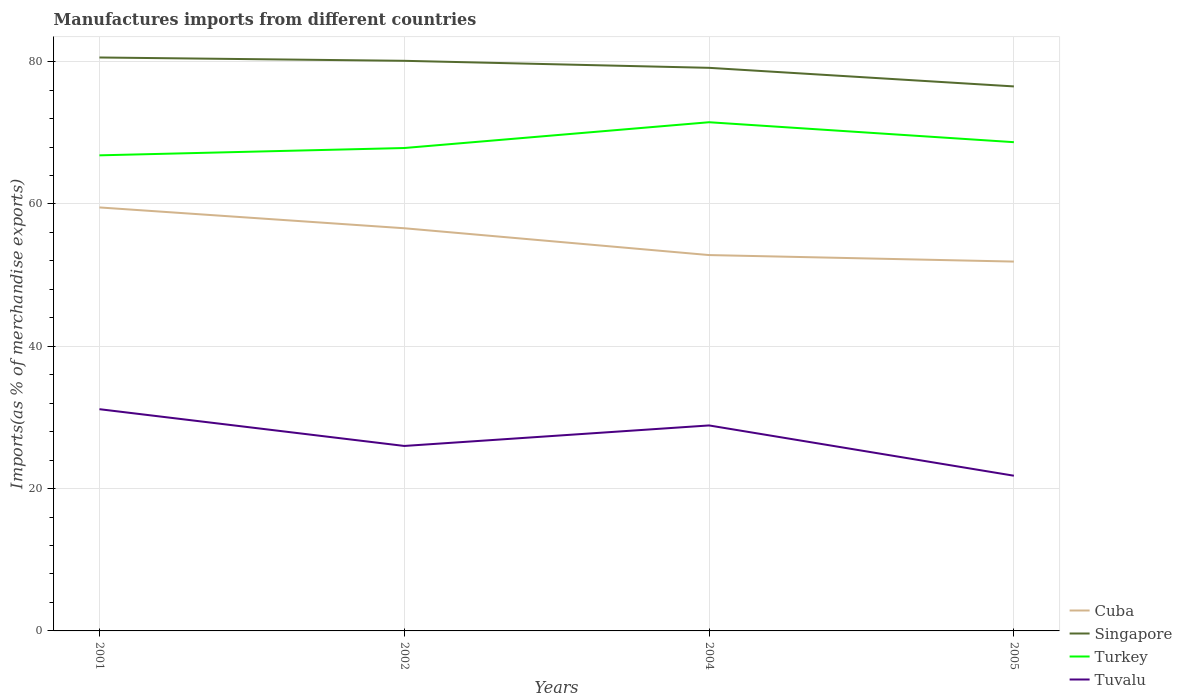How many different coloured lines are there?
Your answer should be compact. 4. Does the line corresponding to Turkey intersect with the line corresponding to Tuvalu?
Keep it short and to the point. No. Across all years, what is the maximum percentage of imports to different countries in Cuba?
Keep it short and to the point. 51.9. In which year was the percentage of imports to different countries in Cuba maximum?
Provide a succinct answer. 2005. What is the total percentage of imports to different countries in Tuvalu in the graph?
Provide a short and direct response. 4.18. What is the difference between the highest and the second highest percentage of imports to different countries in Tuvalu?
Keep it short and to the point. 9.35. What is the difference between two consecutive major ticks on the Y-axis?
Provide a short and direct response. 20. Are the values on the major ticks of Y-axis written in scientific E-notation?
Your response must be concise. No. Does the graph contain grids?
Your response must be concise. Yes. Where does the legend appear in the graph?
Make the answer very short. Bottom right. How many legend labels are there?
Give a very brief answer. 4. What is the title of the graph?
Your response must be concise. Manufactures imports from different countries. Does "Hong Kong" appear as one of the legend labels in the graph?
Offer a very short reply. No. What is the label or title of the Y-axis?
Your response must be concise. Imports(as % of merchandise exports). What is the Imports(as % of merchandise exports) of Cuba in 2001?
Give a very brief answer. 59.51. What is the Imports(as % of merchandise exports) of Singapore in 2001?
Make the answer very short. 80.59. What is the Imports(as % of merchandise exports) of Turkey in 2001?
Provide a succinct answer. 66.84. What is the Imports(as % of merchandise exports) of Tuvalu in 2001?
Make the answer very short. 31.16. What is the Imports(as % of merchandise exports) of Cuba in 2002?
Your response must be concise. 56.59. What is the Imports(as % of merchandise exports) in Singapore in 2002?
Offer a very short reply. 80.12. What is the Imports(as % of merchandise exports) of Turkey in 2002?
Provide a succinct answer. 67.86. What is the Imports(as % of merchandise exports) of Tuvalu in 2002?
Your answer should be very brief. 25.99. What is the Imports(as % of merchandise exports) in Cuba in 2004?
Offer a terse response. 52.82. What is the Imports(as % of merchandise exports) of Singapore in 2004?
Your answer should be compact. 79.13. What is the Imports(as % of merchandise exports) in Turkey in 2004?
Give a very brief answer. 71.49. What is the Imports(as % of merchandise exports) in Tuvalu in 2004?
Provide a short and direct response. 28.88. What is the Imports(as % of merchandise exports) of Cuba in 2005?
Your response must be concise. 51.9. What is the Imports(as % of merchandise exports) in Singapore in 2005?
Give a very brief answer. 76.52. What is the Imports(as % of merchandise exports) of Turkey in 2005?
Offer a terse response. 68.68. What is the Imports(as % of merchandise exports) in Tuvalu in 2005?
Provide a short and direct response. 21.81. Across all years, what is the maximum Imports(as % of merchandise exports) in Cuba?
Offer a terse response. 59.51. Across all years, what is the maximum Imports(as % of merchandise exports) in Singapore?
Offer a terse response. 80.59. Across all years, what is the maximum Imports(as % of merchandise exports) of Turkey?
Your response must be concise. 71.49. Across all years, what is the maximum Imports(as % of merchandise exports) of Tuvalu?
Give a very brief answer. 31.16. Across all years, what is the minimum Imports(as % of merchandise exports) of Cuba?
Your answer should be very brief. 51.9. Across all years, what is the minimum Imports(as % of merchandise exports) of Singapore?
Keep it short and to the point. 76.52. Across all years, what is the minimum Imports(as % of merchandise exports) in Turkey?
Give a very brief answer. 66.84. Across all years, what is the minimum Imports(as % of merchandise exports) in Tuvalu?
Offer a terse response. 21.81. What is the total Imports(as % of merchandise exports) in Cuba in the graph?
Make the answer very short. 220.83. What is the total Imports(as % of merchandise exports) in Singapore in the graph?
Keep it short and to the point. 316.36. What is the total Imports(as % of merchandise exports) in Turkey in the graph?
Your answer should be compact. 274.87. What is the total Imports(as % of merchandise exports) in Tuvalu in the graph?
Keep it short and to the point. 107.84. What is the difference between the Imports(as % of merchandise exports) in Cuba in 2001 and that in 2002?
Offer a very short reply. 2.93. What is the difference between the Imports(as % of merchandise exports) in Singapore in 2001 and that in 2002?
Make the answer very short. 0.47. What is the difference between the Imports(as % of merchandise exports) in Turkey in 2001 and that in 2002?
Ensure brevity in your answer.  -1.03. What is the difference between the Imports(as % of merchandise exports) of Tuvalu in 2001 and that in 2002?
Your answer should be very brief. 5.17. What is the difference between the Imports(as % of merchandise exports) in Cuba in 2001 and that in 2004?
Offer a terse response. 6.69. What is the difference between the Imports(as % of merchandise exports) in Singapore in 2001 and that in 2004?
Make the answer very short. 1.45. What is the difference between the Imports(as % of merchandise exports) in Turkey in 2001 and that in 2004?
Your answer should be compact. -4.65. What is the difference between the Imports(as % of merchandise exports) in Tuvalu in 2001 and that in 2004?
Provide a succinct answer. 2.28. What is the difference between the Imports(as % of merchandise exports) of Cuba in 2001 and that in 2005?
Ensure brevity in your answer.  7.61. What is the difference between the Imports(as % of merchandise exports) in Singapore in 2001 and that in 2005?
Provide a short and direct response. 4.07. What is the difference between the Imports(as % of merchandise exports) of Turkey in 2001 and that in 2005?
Your answer should be compact. -1.85. What is the difference between the Imports(as % of merchandise exports) of Tuvalu in 2001 and that in 2005?
Provide a short and direct response. 9.35. What is the difference between the Imports(as % of merchandise exports) of Cuba in 2002 and that in 2004?
Make the answer very short. 3.77. What is the difference between the Imports(as % of merchandise exports) in Singapore in 2002 and that in 2004?
Give a very brief answer. 0.99. What is the difference between the Imports(as % of merchandise exports) of Turkey in 2002 and that in 2004?
Your answer should be compact. -3.62. What is the difference between the Imports(as % of merchandise exports) of Tuvalu in 2002 and that in 2004?
Provide a short and direct response. -2.88. What is the difference between the Imports(as % of merchandise exports) of Cuba in 2002 and that in 2005?
Your answer should be compact. 4.68. What is the difference between the Imports(as % of merchandise exports) in Singapore in 2002 and that in 2005?
Your response must be concise. 3.6. What is the difference between the Imports(as % of merchandise exports) in Turkey in 2002 and that in 2005?
Offer a terse response. -0.82. What is the difference between the Imports(as % of merchandise exports) of Tuvalu in 2002 and that in 2005?
Ensure brevity in your answer.  4.18. What is the difference between the Imports(as % of merchandise exports) of Cuba in 2004 and that in 2005?
Provide a short and direct response. 0.92. What is the difference between the Imports(as % of merchandise exports) of Singapore in 2004 and that in 2005?
Your answer should be compact. 2.61. What is the difference between the Imports(as % of merchandise exports) in Turkey in 2004 and that in 2005?
Offer a very short reply. 2.8. What is the difference between the Imports(as % of merchandise exports) of Tuvalu in 2004 and that in 2005?
Offer a very short reply. 7.07. What is the difference between the Imports(as % of merchandise exports) in Cuba in 2001 and the Imports(as % of merchandise exports) in Singapore in 2002?
Offer a very short reply. -20.61. What is the difference between the Imports(as % of merchandise exports) of Cuba in 2001 and the Imports(as % of merchandise exports) of Turkey in 2002?
Provide a succinct answer. -8.35. What is the difference between the Imports(as % of merchandise exports) in Cuba in 2001 and the Imports(as % of merchandise exports) in Tuvalu in 2002?
Give a very brief answer. 33.52. What is the difference between the Imports(as % of merchandise exports) of Singapore in 2001 and the Imports(as % of merchandise exports) of Turkey in 2002?
Your response must be concise. 12.72. What is the difference between the Imports(as % of merchandise exports) in Singapore in 2001 and the Imports(as % of merchandise exports) in Tuvalu in 2002?
Make the answer very short. 54.59. What is the difference between the Imports(as % of merchandise exports) of Turkey in 2001 and the Imports(as % of merchandise exports) of Tuvalu in 2002?
Make the answer very short. 40.84. What is the difference between the Imports(as % of merchandise exports) in Cuba in 2001 and the Imports(as % of merchandise exports) in Singapore in 2004?
Ensure brevity in your answer.  -19.62. What is the difference between the Imports(as % of merchandise exports) in Cuba in 2001 and the Imports(as % of merchandise exports) in Turkey in 2004?
Your answer should be compact. -11.97. What is the difference between the Imports(as % of merchandise exports) of Cuba in 2001 and the Imports(as % of merchandise exports) of Tuvalu in 2004?
Give a very brief answer. 30.64. What is the difference between the Imports(as % of merchandise exports) of Singapore in 2001 and the Imports(as % of merchandise exports) of Turkey in 2004?
Your response must be concise. 9.1. What is the difference between the Imports(as % of merchandise exports) in Singapore in 2001 and the Imports(as % of merchandise exports) in Tuvalu in 2004?
Offer a terse response. 51.71. What is the difference between the Imports(as % of merchandise exports) in Turkey in 2001 and the Imports(as % of merchandise exports) in Tuvalu in 2004?
Your response must be concise. 37.96. What is the difference between the Imports(as % of merchandise exports) of Cuba in 2001 and the Imports(as % of merchandise exports) of Singapore in 2005?
Your answer should be very brief. -17.01. What is the difference between the Imports(as % of merchandise exports) in Cuba in 2001 and the Imports(as % of merchandise exports) in Turkey in 2005?
Provide a short and direct response. -9.17. What is the difference between the Imports(as % of merchandise exports) in Cuba in 2001 and the Imports(as % of merchandise exports) in Tuvalu in 2005?
Make the answer very short. 37.7. What is the difference between the Imports(as % of merchandise exports) of Singapore in 2001 and the Imports(as % of merchandise exports) of Turkey in 2005?
Your answer should be very brief. 11.9. What is the difference between the Imports(as % of merchandise exports) of Singapore in 2001 and the Imports(as % of merchandise exports) of Tuvalu in 2005?
Provide a succinct answer. 58.78. What is the difference between the Imports(as % of merchandise exports) of Turkey in 2001 and the Imports(as % of merchandise exports) of Tuvalu in 2005?
Make the answer very short. 45.02. What is the difference between the Imports(as % of merchandise exports) of Cuba in 2002 and the Imports(as % of merchandise exports) of Singapore in 2004?
Your answer should be compact. -22.55. What is the difference between the Imports(as % of merchandise exports) in Cuba in 2002 and the Imports(as % of merchandise exports) in Turkey in 2004?
Offer a terse response. -14.9. What is the difference between the Imports(as % of merchandise exports) of Cuba in 2002 and the Imports(as % of merchandise exports) of Tuvalu in 2004?
Make the answer very short. 27.71. What is the difference between the Imports(as % of merchandise exports) in Singapore in 2002 and the Imports(as % of merchandise exports) in Turkey in 2004?
Give a very brief answer. 8.63. What is the difference between the Imports(as % of merchandise exports) of Singapore in 2002 and the Imports(as % of merchandise exports) of Tuvalu in 2004?
Give a very brief answer. 51.24. What is the difference between the Imports(as % of merchandise exports) of Turkey in 2002 and the Imports(as % of merchandise exports) of Tuvalu in 2004?
Ensure brevity in your answer.  38.99. What is the difference between the Imports(as % of merchandise exports) of Cuba in 2002 and the Imports(as % of merchandise exports) of Singapore in 2005?
Offer a terse response. -19.93. What is the difference between the Imports(as % of merchandise exports) of Cuba in 2002 and the Imports(as % of merchandise exports) of Turkey in 2005?
Make the answer very short. -12.1. What is the difference between the Imports(as % of merchandise exports) in Cuba in 2002 and the Imports(as % of merchandise exports) in Tuvalu in 2005?
Keep it short and to the point. 34.78. What is the difference between the Imports(as % of merchandise exports) of Singapore in 2002 and the Imports(as % of merchandise exports) of Turkey in 2005?
Your answer should be compact. 11.43. What is the difference between the Imports(as % of merchandise exports) of Singapore in 2002 and the Imports(as % of merchandise exports) of Tuvalu in 2005?
Provide a succinct answer. 58.31. What is the difference between the Imports(as % of merchandise exports) in Turkey in 2002 and the Imports(as % of merchandise exports) in Tuvalu in 2005?
Make the answer very short. 46.05. What is the difference between the Imports(as % of merchandise exports) in Cuba in 2004 and the Imports(as % of merchandise exports) in Singapore in 2005?
Make the answer very short. -23.7. What is the difference between the Imports(as % of merchandise exports) of Cuba in 2004 and the Imports(as % of merchandise exports) of Turkey in 2005?
Provide a short and direct response. -15.86. What is the difference between the Imports(as % of merchandise exports) of Cuba in 2004 and the Imports(as % of merchandise exports) of Tuvalu in 2005?
Your answer should be compact. 31.01. What is the difference between the Imports(as % of merchandise exports) in Singapore in 2004 and the Imports(as % of merchandise exports) in Turkey in 2005?
Offer a terse response. 10.45. What is the difference between the Imports(as % of merchandise exports) in Singapore in 2004 and the Imports(as % of merchandise exports) in Tuvalu in 2005?
Offer a terse response. 57.32. What is the difference between the Imports(as % of merchandise exports) of Turkey in 2004 and the Imports(as % of merchandise exports) of Tuvalu in 2005?
Your answer should be very brief. 49.68. What is the average Imports(as % of merchandise exports) in Cuba per year?
Offer a terse response. 55.21. What is the average Imports(as % of merchandise exports) of Singapore per year?
Provide a succinct answer. 79.09. What is the average Imports(as % of merchandise exports) in Turkey per year?
Provide a short and direct response. 68.72. What is the average Imports(as % of merchandise exports) in Tuvalu per year?
Provide a succinct answer. 26.96. In the year 2001, what is the difference between the Imports(as % of merchandise exports) of Cuba and Imports(as % of merchandise exports) of Singapore?
Provide a short and direct response. -21.07. In the year 2001, what is the difference between the Imports(as % of merchandise exports) in Cuba and Imports(as % of merchandise exports) in Turkey?
Offer a very short reply. -7.32. In the year 2001, what is the difference between the Imports(as % of merchandise exports) in Cuba and Imports(as % of merchandise exports) in Tuvalu?
Keep it short and to the point. 28.35. In the year 2001, what is the difference between the Imports(as % of merchandise exports) of Singapore and Imports(as % of merchandise exports) of Turkey?
Provide a short and direct response. 13.75. In the year 2001, what is the difference between the Imports(as % of merchandise exports) of Singapore and Imports(as % of merchandise exports) of Tuvalu?
Offer a terse response. 49.43. In the year 2001, what is the difference between the Imports(as % of merchandise exports) of Turkey and Imports(as % of merchandise exports) of Tuvalu?
Provide a short and direct response. 35.67. In the year 2002, what is the difference between the Imports(as % of merchandise exports) in Cuba and Imports(as % of merchandise exports) in Singapore?
Offer a terse response. -23.53. In the year 2002, what is the difference between the Imports(as % of merchandise exports) of Cuba and Imports(as % of merchandise exports) of Turkey?
Offer a terse response. -11.28. In the year 2002, what is the difference between the Imports(as % of merchandise exports) of Cuba and Imports(as % of merchandise exports) of Tuvalu?
Ensure brevity in your answer.  30.59. In the year 2002, what is the difference between the Imports(as % of merchandise exports) in Singapore and Imports(as % of merchandise exports) in Turkey?
Your response must be concise. 12.26. In the year 2002, what is the difference between the Imports(as % of merchandise exports) in Singapore and Imports(as % of merchandise exports) in Tuvalu?
Your response must be concise. 54.12. In the year 2002, what is the difference between the Imports(as % of merchandise exports) in Turkey and Imports(as % of merchandise exports) in Tuvalu?
Give a very brief answer. 41.87. In the year 2004, what is the difference between the Imports(as % of merchandise exports) of Cuba and Imports(as % of merchandise exports) of Singapore?
Your response must be concise. -26.31. In the year 2004, what is the difference between the Imports(as % of merchandise exports) of Cuba and Imports(as % of merchandise exports) of Turkey?
Your answer should be very brief. -18.67. In the year 2004, what is the difference between the Imports(as % of merchandise exports) of Cuba and Imports(as % of merchandise exports) of Tuvalu?
Offer a terse response. 23.94. In the year 2004, what is the difference between the Imports(as % of merchandise exports) of Singapore and Imports(as % of merchandise exports) of Turkey?
Offer a terse response. 7.65. In the year 2004, what is the difference between the Imports(as % of merchandise exports) in Singapore and Imports(as % of merchandise exports) in Tuvalu?
Provide a short and direct response. 50.26. In the year 2004, what is the difference between the Imports(as % of merchandise exports) in Turkey and Imports(as % of merchandise exports) in Tuvalu?
Give a very brief answer. 42.61. In the year 2005, what is the difference between the Imports(as % of merchandise exports) in Cuba and Imports(as % of merchandise exports) in Singapore?
Provide a succinct answer. -24.62. In the year 2005, what is the difference between the Imports(as % of merchandise exports) of Cuba and Imports(as % of merchandise exports) of Turkey?
Offer a very short reply. -16.78. In the year 2005, what is the difference between the Imports(as % of merchandise exports) in Cuba and Imports(as % of merchandise exports) in Tuvalu?
Your response must be concise. 30.09. In the year 2005, what is the difference between the Imports(as % of merchandise exports) in Singapore and Imports(as % of merchandise exports) in Turkey?
Your answer should be very brief. 7.84. In the year 2005, what is the difference between the Imports(as % of merchandise exports) of Singapore and Imports(as % of merchandise exports) of Tuvalu?
Ensure brevity in your answer.  54.71. In the year 2005, what is the difference between the Imports(as % of merchandise exports) in Turkey and Imports(as % of merchandise exports) in Tuvalu?
Ensure brevity in your answer.  46.87. What is the ratio of the Imports(as % of merchandise exports) in Cuba in 2001 to that in 2002?
Your answer should be very brief. 1.05. What is the ratio of the Imports(as % of merchandise exports) of Tuvalu in 2001 to that in 2002?
Offer a terse response. 1.2. What is the ratio of the Imports(as % of merchandise exports) of Cuba in 2001 to that in 2004?
Give a very brief answer. 1.13. What is the ratio of the Imports(as % of merchandise exports) of Singapore in 2001 to that in 2004?
Your answer should be very brief. 1.02. What is the ratio of the Imports(as % of merchandise exports) of Turkey in 2001 to that in 2004?
Your answer should be very brief. 0.93. What is the ratio of the Imports(as % of merchandise exports) in Tuvalu in 2001 to that in 2004?
Offer a very short reply. 1.08. What is the ratio of the Imports(as % of merchandise exports) in Cuba in 2001 to that in 2005?
Provide a succinct answer. 1.15. What is the ratio of the Imports(as % of merchandise exports) of Singapore in 2001 to that in 2005?
Your answer should be compact. 1.05. What is the ratio of the Imports(as % of merchandise exports) in Turkey in 2001 to that in 2005?
Make the answer very short. 0.97. What is the ratio of the Imports(as % of merchandise exports) in Tuvalu in 2001 to that in 2005?
Give a very brief answer. 1.43. What is the ratio of the Imports(as % of merchandise exports) of Cuba in 2002 to that in 2004?
Your answer should be compact. 1.07. What is the ratio of the Imports(as % of merchandise exports) in Singapore in 2002 to that in 2004?
Offer a very short reply. 1.01. What is the ratio of the Imports(as % of merchandise exports) in Turkey in 2002 to that in 2004?
Your response must be concise. 0.95. What is the ratio of the Imports(as % of merchandise exports) of Tuvalu in 2002 to that in 2004?
Your response must be concise. 0.9. What is the ratio of the Imports(as % of merchandise exports) in Cuba in 2002 to that in 2005?
Provide a short and direct response. 1.09. What is the ratio of the Imports(as % of merchandise exports) in Singapore in 2002 to that in 2005?
Your answer should be very brief. 1.05. What is the ratio of the Imports(as % of merchandise exports) of Tuvalu in 2002 to that in 2005?
Offer a very short reply. 1.19. What is the ratio of the Imports(as % of merchandise exports) of Cuba in 2004 to that in 2005?
Provide a succinct answer. 1.02. What is the ratio of the Imports(as % of merchandise exports) in Singapore in 2004 to that in 2005?
Offer a terse response. 1.03. What is the ratio of the Imports(as % of merchandise exports) in Turkey in 2004 to that in 2005?
Your answer should be compact. 1.04. What is the ratio of the Imports(as % of merchandise exports) in Tuvalu in 2004 to that in 2005?
Offer a terse response. 1.32. What is the difference between the highest and the second highest Imports(as % of merchandise exports) in Cuba?
Keep it short and to the point. 2.93. What is the difference between the highest and the second highest Imports(as % of merchandise exports) in Singapore?
Offer a terse response. 0.47. What is the difference between the highest and the second highest Imports(as % of merchandise exports) of Turkey?
Your answer should be very brief. 2.8. What is the difference between the highest and the second highest Imports(as % of merchandise exports) in Tuvalu?
Offer a very short reply. 2.28. What is the difference between the highest and the lowest Imports(as % of merchandise exports) in Cuba?
Provide a succinct answer. 7.61. What is the difference between the highest and the lowest Imports(as % of merchandise exports) of Singapore?
Give a very brief answer. 4.07. What is the difference between the highest and the lowest Imports(as % of merchandise exports) of Turkey?
Your answer should be very brief. 4.65. What is the difference between the highest and the lowest Imports(as % of merchandise exports) of Tuvalu?
Give a very brief answer. 9.35. 